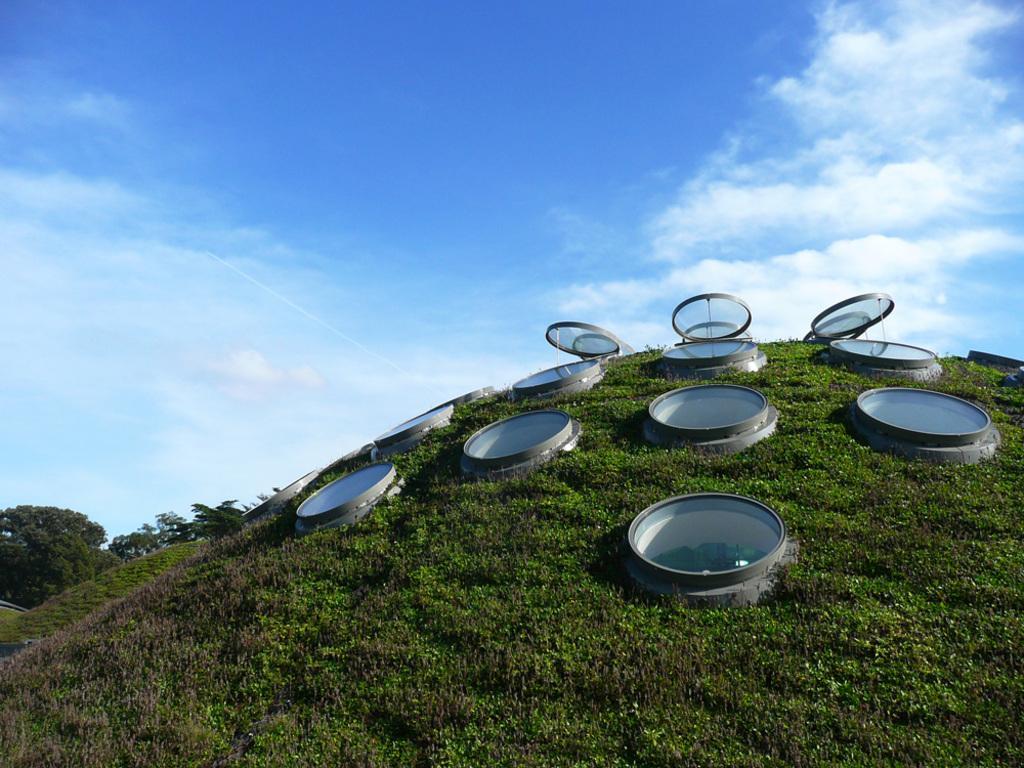Could you give a brief overview of what you see in this image? This image consists of some caps. This looks like there's a hole. There is grass in this image. There is sky at the top. There are trees on the left side. 